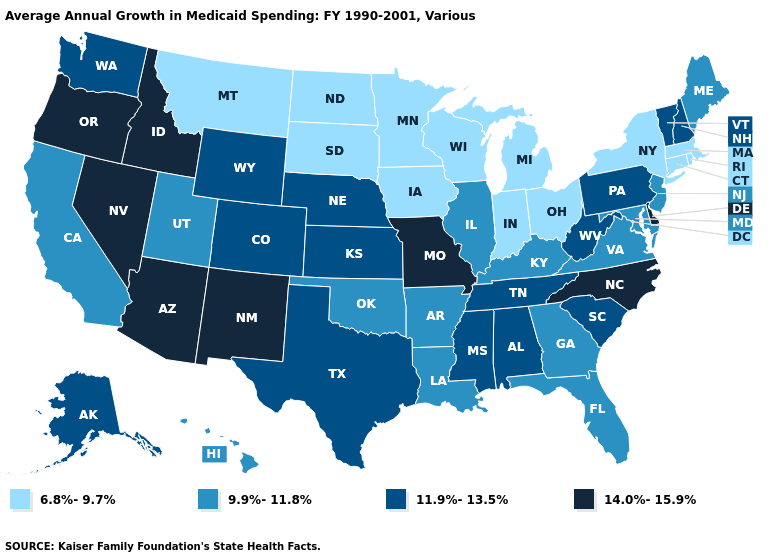What is the lowest value in states that border Arkansas?
Short answer required. 9.9%-11.8%. Does the map have missing data?
Concise answer only. No. Does Wisconsin have a lower value than Montana?
Give a very brief answer. No. What is the value of Virginia?
Answer briefly. 9.9%-11.8%. Does New Hampshire have the highest value in the Northeast?
Keep it brief. Yes. What is the highest value in states that border Pennsylvania?
Keep it brief. 14.0%-15.9%. Name the states that have a value in the range 6.8%-9.7%?
Keep it brief. Connecticut, Indiana, Iowa, Massachusetts, Michigan, Minnesota, Montana, New York, North Dakota, Ohio, Rhode Island, South Dakota, Wisconsin. What is the value of Louisiana?
Answer briefly. 9.9%-11.8%. Which states have the highest value in the USA?
Answer briefly. Arizona, Delaware, Idaho, Missouri, Nevada, New Mexico, North Carolina, Oregon. What is the value of Indiana?
Keep it brief. 6.8%-9.7%. Name the states that have a value in the range 14.0%-15.9%?
Short answer required. Arizona, Delaware, Idaho, Missouri, Nevada, New Mexico, North Carolina, Oregon. Does Hawaii have a higher value than New York?
Answer briefly. Yes. Does the first symbol in the legend represent the smallest category?
Short answer required. Yes. Name the states that have a value in the range 14.0%-15.9%?
Short answer required. Arizona, Delaware, Idaho, Missouri, Nevada, New Mexico, North Carolina, Oregon. Which states have the highest value in the USA?
Give a very brief answer. Arizona, Delaware, Idaho, Missouri, Nevada, New Mexico, North Carolina, Oregon. 